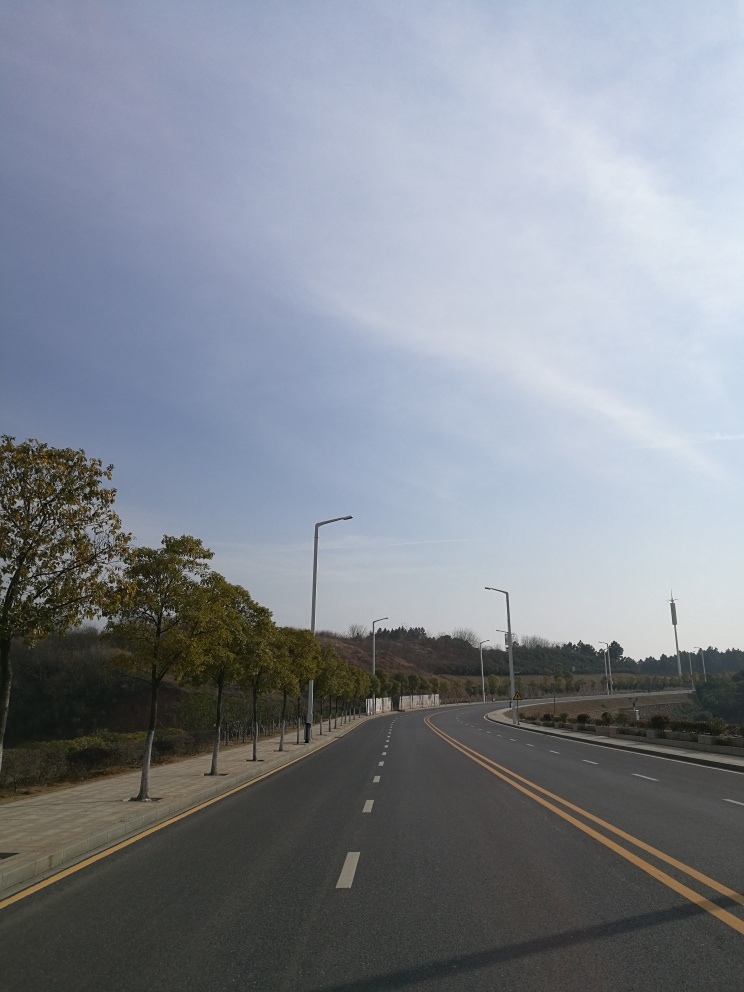Does this road look like it's frequently used? The road looks well-maintained with clear markings, suggesting it's designed for regular use. However, at the moment of this photo, it appears unusually empty, which could be due to the time of day or less frequent weekend or holiday traffic. 